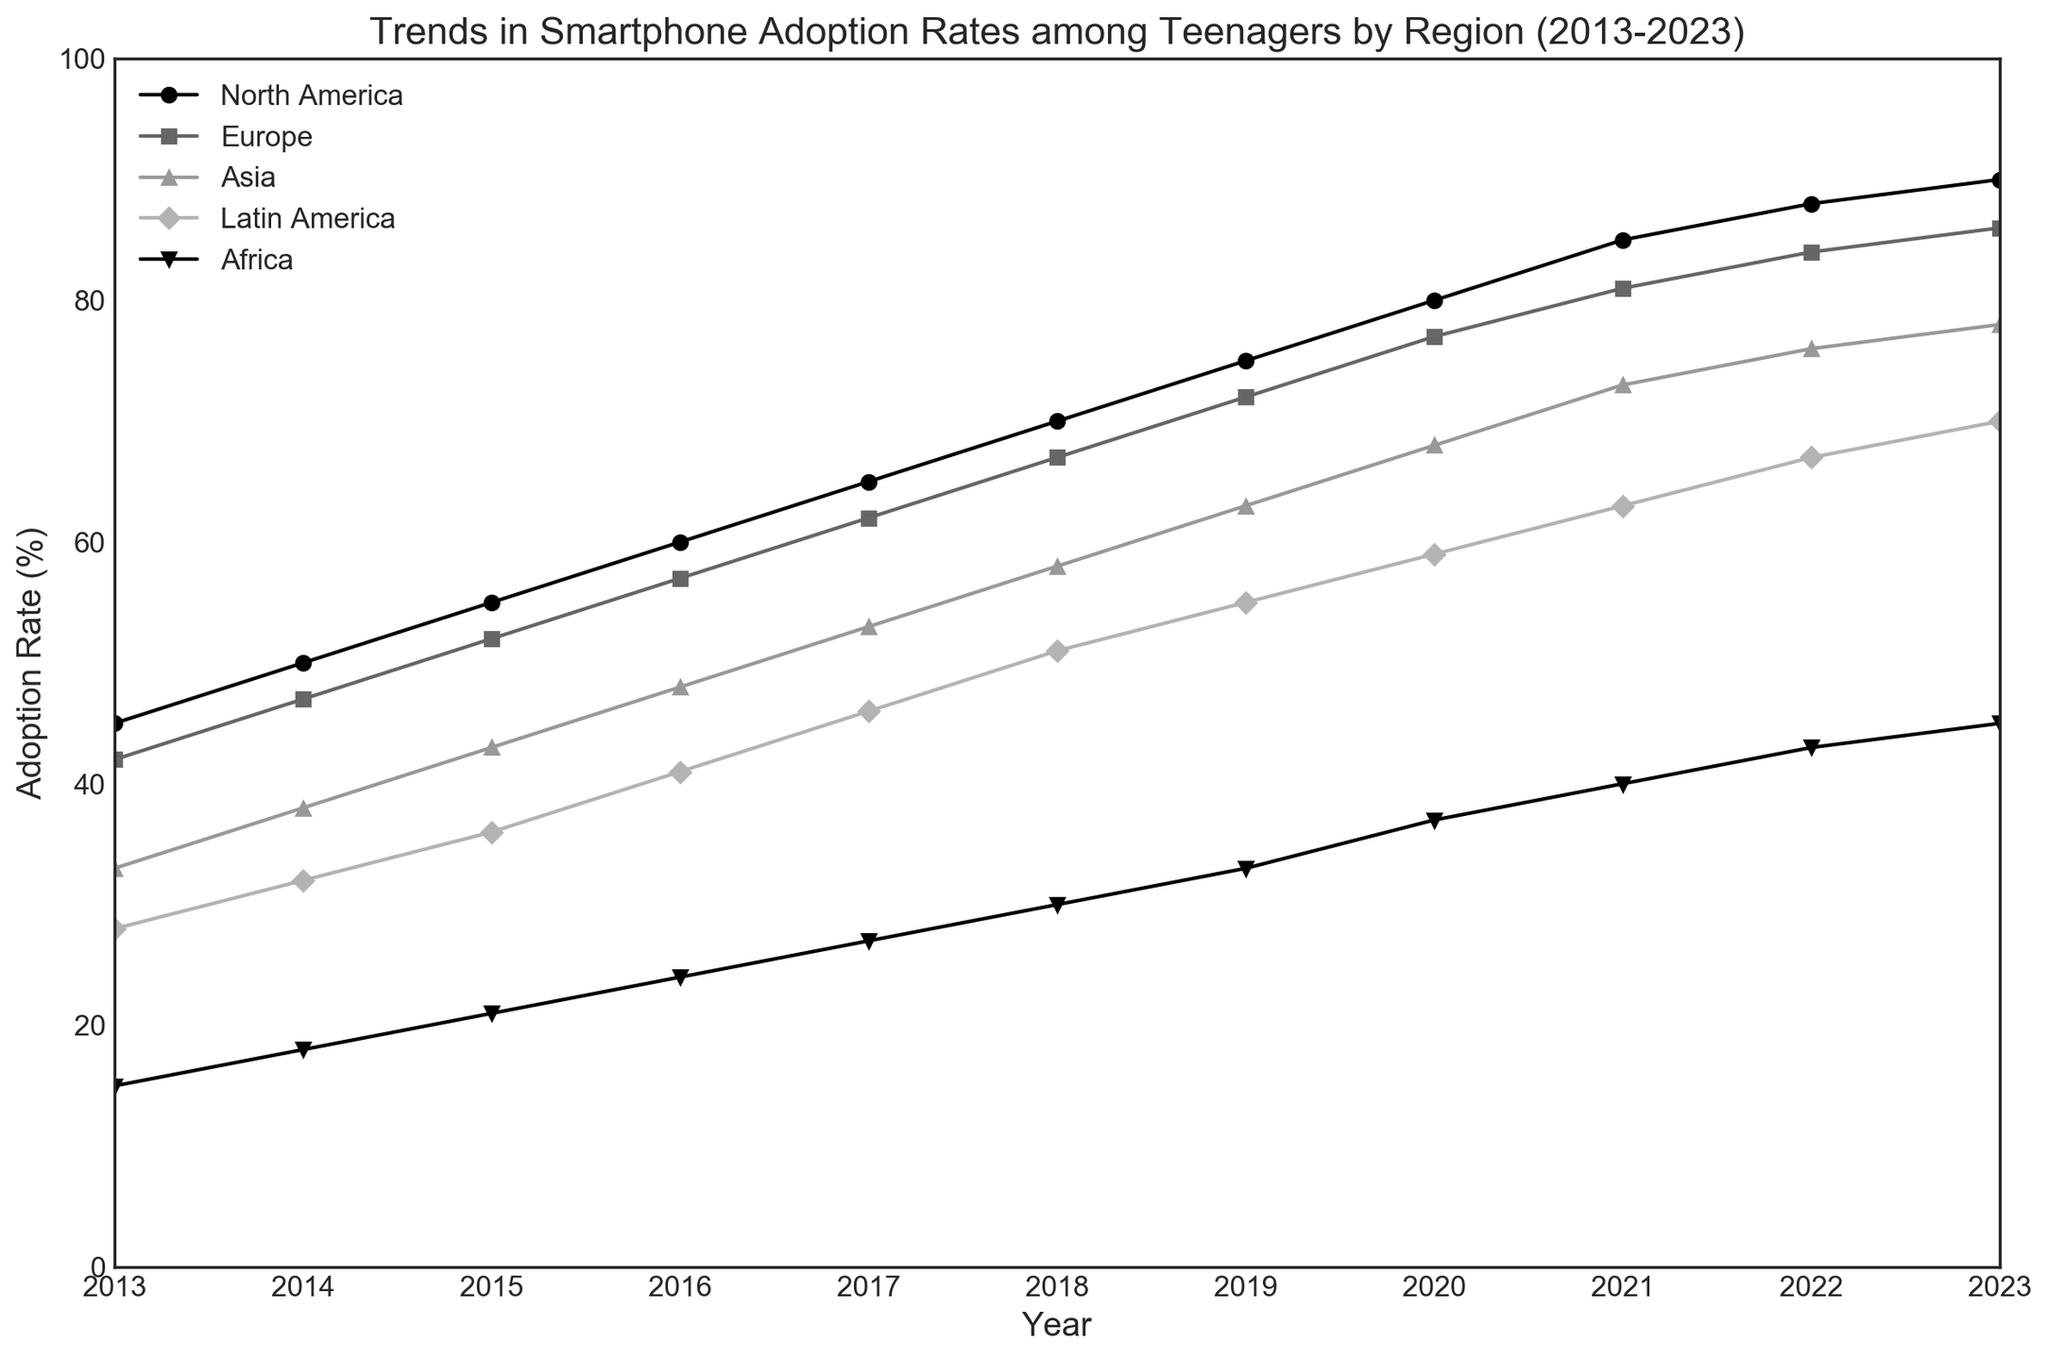Which region had the highest adoption rate in 2023? The chart shows that the adoption rate for North America in 2023 is the highest among all regions.
Answer: North America How did the adoption rate in Europe change from 2013 to 2023? In 2013, Europe’s adoption rate was 42%. By 2023, it increased to 86%. Thus, the change = 86 - 42 = 44%.
Answer: Increased by 44% Which region showed the steepest increase in adoption rates between 2016 and 2020? By observing the slopes of the line segments between 2016 and 2020, North America’s increase from 60% to 80% is the steepest, i.e., 80 - 60 = 20%.
Answer: North America In 2023, what is the difference in adoption rates between Latin America and Africa? The adoption rate in 2023 for Latin America is 70%, and for Africa, it is 45%. Difference = 70 - 45 = 25%.
Answer: 25% Which two regions had the closest adoption rates in 2020? In 2020, Europe had 77% and Asia had 68%. The difference between the two is 77 - 68 = 9%, which is the smallest difference compared to other regions.
Answer: Europe and Asia What is the average adoption rate for Asia between 2013 and 2023? Summing up Asia’s adoption rates from 2013 to 2023: 33 + 38 + 43 + 48 + 53 + 58 + 63 + 68 + 73 + 76 + 78. The total is 631. Average = 631 / 11 ≈ 57.36%.
Answer: 57.36% During which year did Latin America surpass a 50% adoption rate? Looking at Latin America’s progression, it surpassed 50% between 2017 (46%) and 2018 (51%). Therefore, 2018 is when it first surpassed 50%.
Answer: 2018 Compare the adoption rate growth of Africa and Asia from 2013 to 2023. Which region had a higher growth rate? From 2013 to 2023, Africa’s adoption rate grew from 15% to 45% (growth = 45 - 15 = 30%). Asia’s adoption rate grew from 33% to 78% (growth = 78 - 33 = 45%). Asia had a higher growth rate.
Answer: Asia What is the total increase in the adoption rates for Latin America from 2013 to 2023? In 2013, Latin America had an adoption rate of 28%. By 2023, it was 70%. The increase is 70 - 28 = 42%.
Answer: 42% 